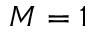Convert formula to latex. <formula><loc_0><loc_0><loc_500><loc_500>M = 1</formula> 